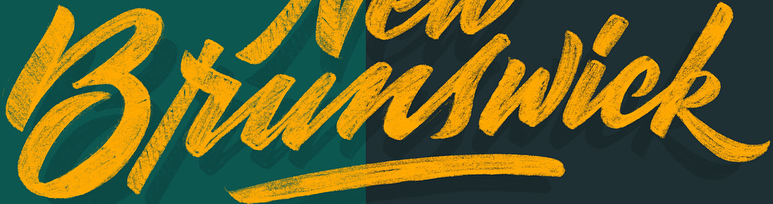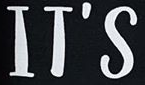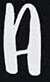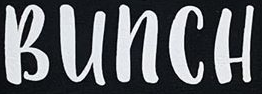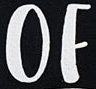Read the text content from these images in order, separated by a semicolon. Brunswick; IT'S; A; BUNCH; OF 